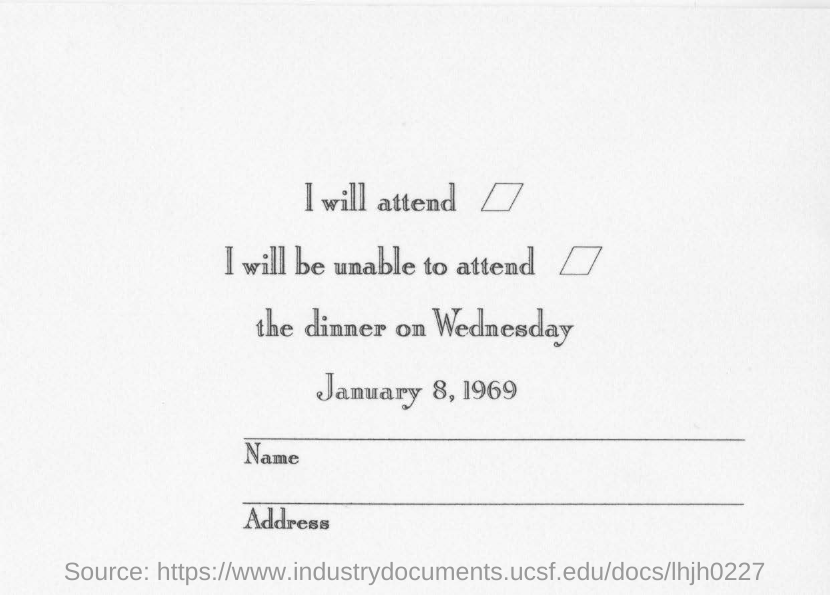What is the date mentioned?
Make the answer very short. January 8, 1969. On which day is the dinner scheduled on?
Provide a short and direct response. Wednesday. What is the first option mentioned?
Give a very brief answer. I will attend. What is the second option mentioned?
Your answer should be very brief. I will be unable to attend. 